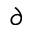Convert formula to latex. <formula><loc_0><loc_0><loc_500><loc_500>\partial</formula> 